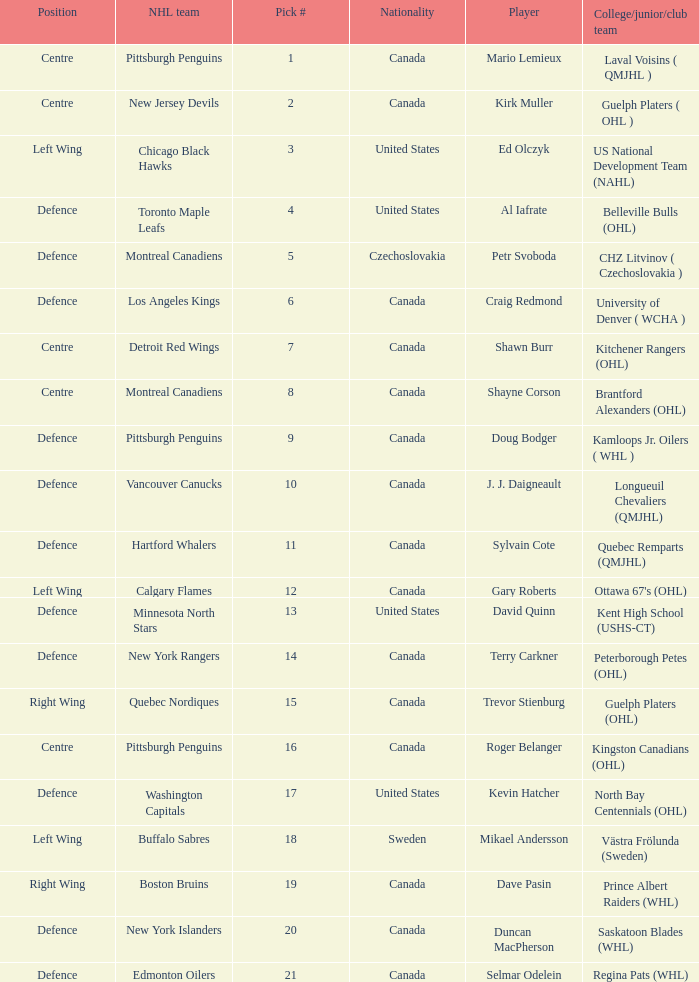What player is draft pick 17? Kevin Hatcher. 